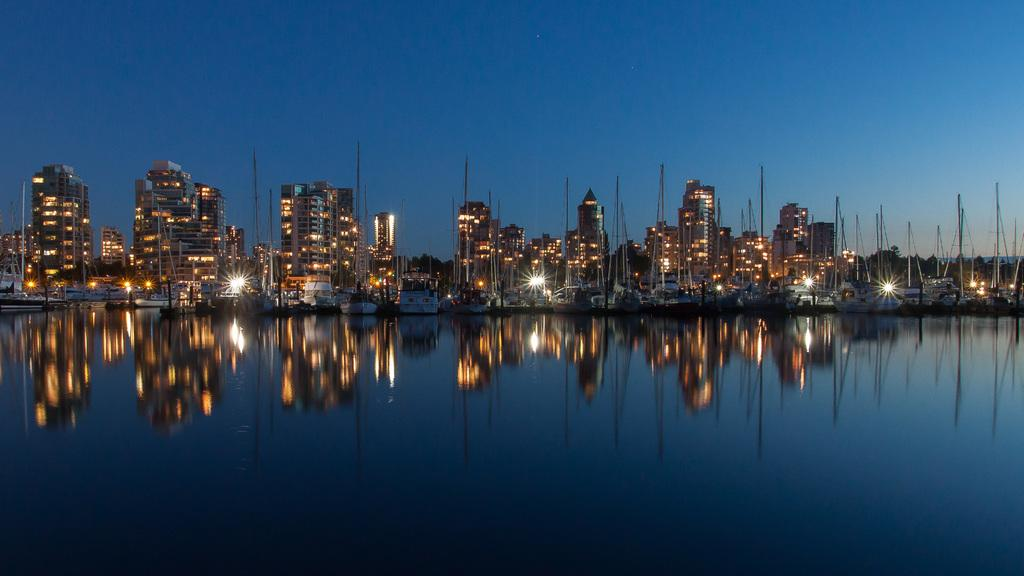What is located in the center of the image? There are buildings, boats, and lights in the center of the image. What is the primary element at the bottom of the image? There is water at the bottom of the image. What can be seen in the background of the image? There is sky visible in the background of the image. Can you hear the bell ringing in the image? There is no bell present in the image, so it is not possible to hear it ringing. 